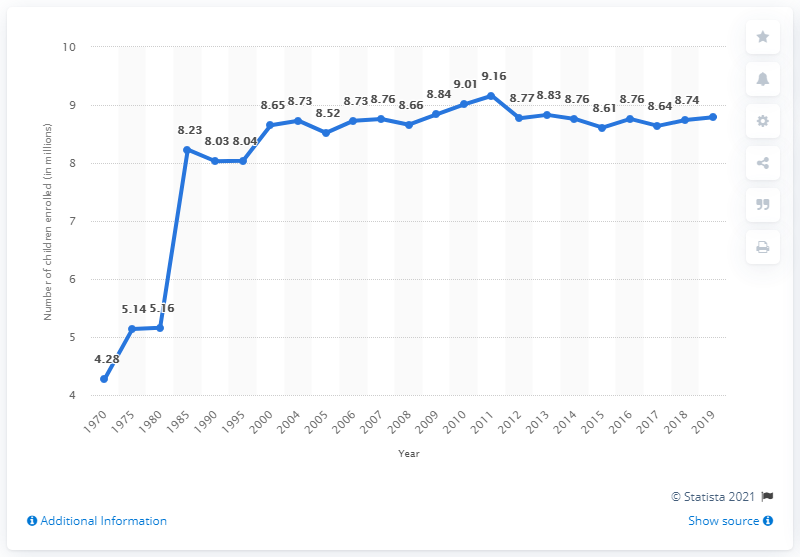Indicate a few pertinent items in this graphic. In 2019, the United States had 8.79 children enrolled in nursery or kindergarten programs. In 1970, a total of 4.28 million children were enrolled in pre-primary school programs. In 1970, 4.28 children were enrolled in pre-primary school programs. 